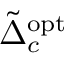Convert formula to latex. <formula><loc_0><loc_0><loc_500><loc_500>\tilde { \Delta } _ { c } ^ { o p t }</formula> 